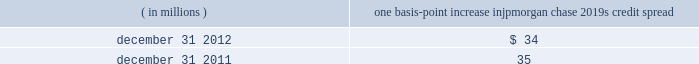Jpmorgan chase & co./2012 annual report 167 the chart shows that for year ended december 31 , 2012 , the firm posted market risk related gains on 220 of the 261 days in this period , with gains on eight days exceeding $ 200 million .
The chart includes year to date losses incurred in the synthetic credit portfolio .
Cib and credit portfolio posted market risk-related gains on 254 days in the period .
The inset graph looks at those days on which the firm experienced losses and depicts the amount by which var exceeded the actual loss on each of those days .
Of the losses that were sustained on the 41 days of the 261 days in the trading period , the firm sustained losses that exceeded the var measure on three of those days .
These losses in excess of the var all occurred in the second quarter of 2012 and were due to the adverse effect of market movements on risk positions in the synthetic credit portfolio held by cio .
During the year ended december 31 , 2012 , cib and credit portfolio experienced seven loss days ; none of the losses on those days exceeded their respective var measures .
Other risk measures debit valuation adjustment sensitivity the table provides information about the gross sensitivity of dva to a one-basis-point increase in jpmorgan chase 2019s credit spreads .
This sensitivity represents the impact from a one-basis-point parallel shift in jpmorgan chase 2019s entire credit curve .
However , the sensitivity at a single point in time multiplied by the change in credit spread at a single maturity point may not be representative of the actual dva gain or loss realized within a period .
The actual results reflect the movement in credit spreads across various maturities , which typically do not move in a parallel fashion , and is the product of a constantly changing exposure profile , among other factors .
Debit valuation adjustment sensitivity ( in millions ) one basis-point increase in jpmorgan chase 2019s credit spread .
Economic-value stress testing along with var , stress testing is important in measuring and controlling risk .
While var reflects the risk of loss due to adverse changes in markets using recent historical market behavior as an indicator of losses , stress testing captures the firm 2019s exposure to unlikely but plausible events in abnormal markets .
The firm runs weekly stress tests on market-related risks across the lines of business using multiple scenarios that assume significant changes in risk factors such as credit spreads , equity prices , interest rates , currency rates or commodity prices .
The framework uses a grid-based approach , which calculates multiple magnitudes of stress for both market rallies and market sell-offs for .
How often did the firm sustain losses that exceeded the var measure? 
Computations: (3 / 261)
Answer: 0.01149. 